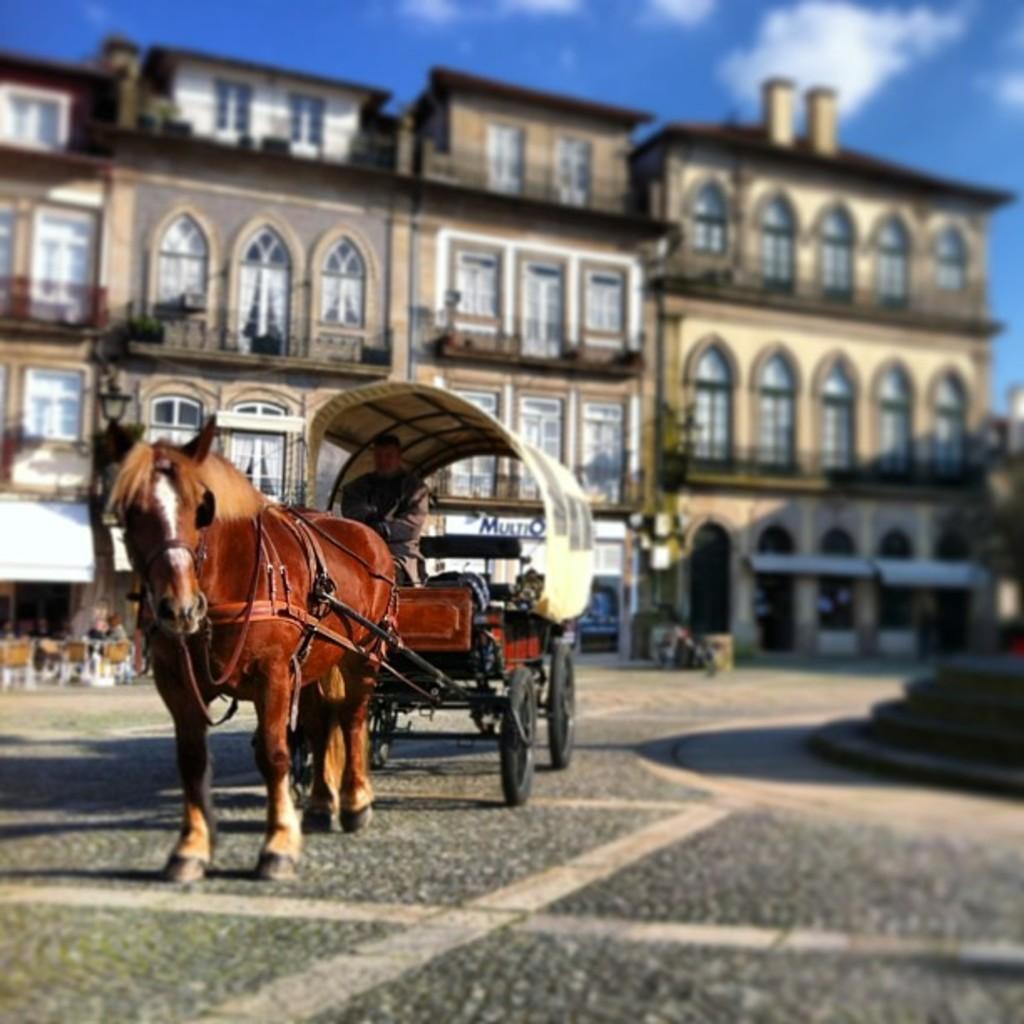Could you give a brief overview of what you see in this image? In this picture we can see a horse cart on the ground, here we can see a person and some objects and in the background we can see buildings, sky with clouds. 